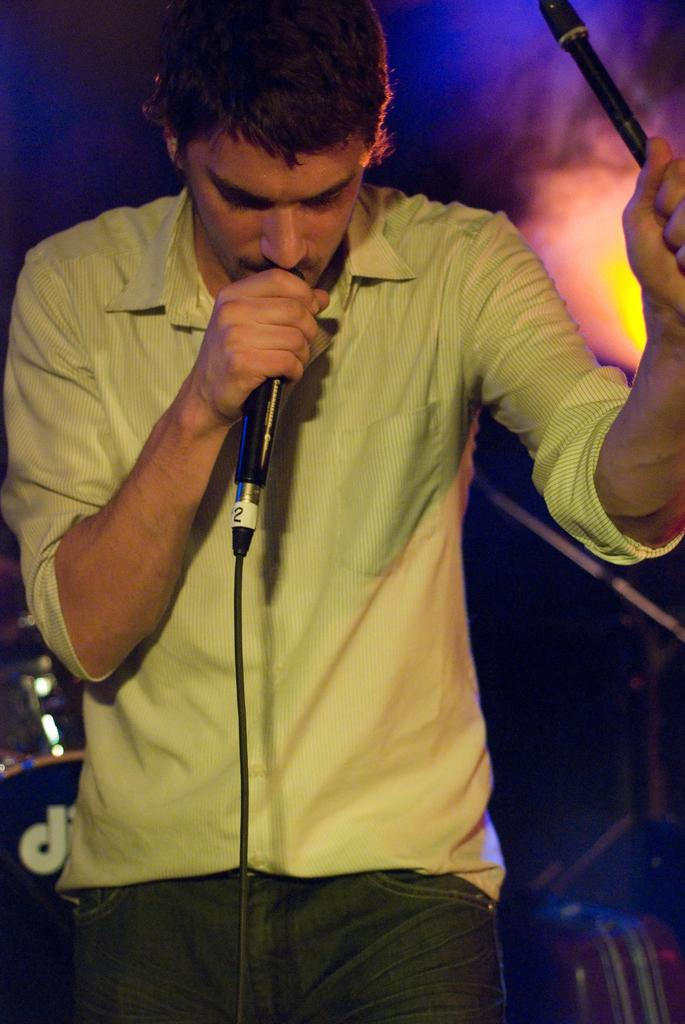What is the man in the image doing? The man is standing in the image and holding a mic. What can be seen in the background of the image? There is a band in the background of the image. Can you describe the lighting in the image? There is a light on the right side of the image. What type of berry is being passed around by the flock in the image? There is no flock or berry present in the image. What message of peace is being conveyed by the man in the image? The image does not convey a message of peace, as it features a man holding a mic and a band in the background. 